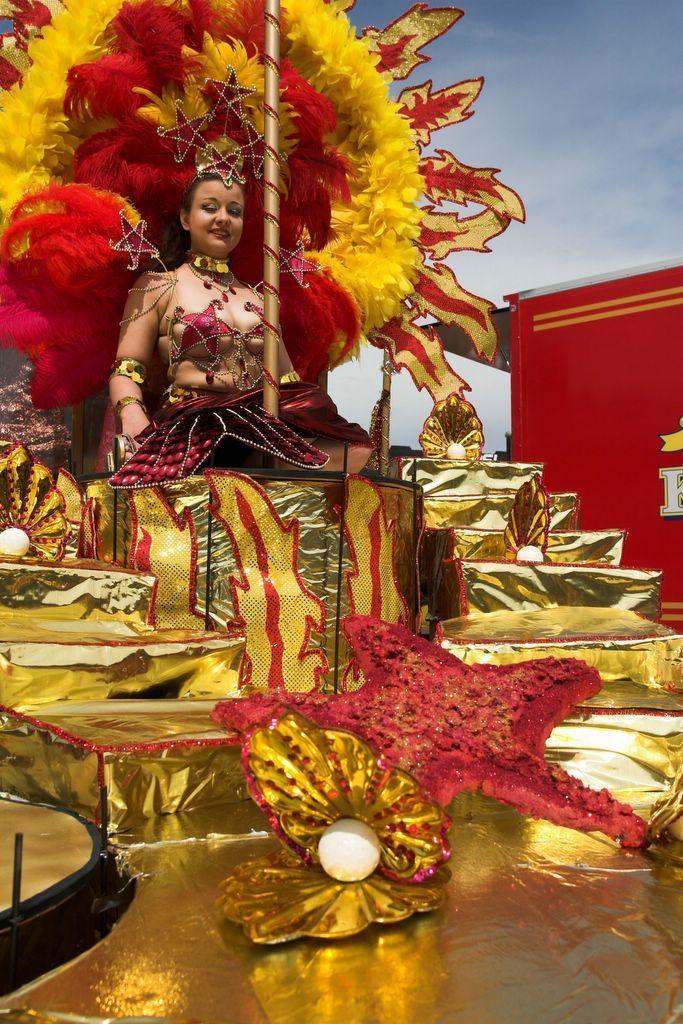Could you give a brief overview of what you see in this image? In the center of the image, we can see a lady wearing costume and sitting on the palanquin and we can see some decor items and a shed with some text. At the top, there is sky. 